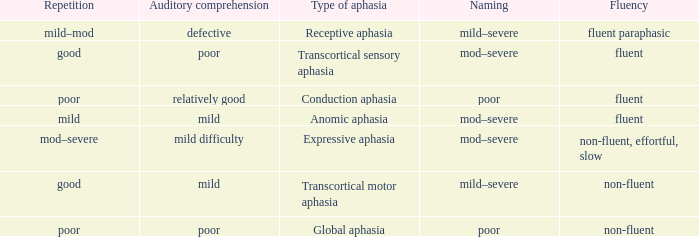Name the comprehension for non-fluent, effortful, slow Mild difficulty. 